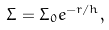Convert formula to latex. <formula><loc_0><loc_0><loc_500><loc_500>\Sigma = \Sigma _ { 0 } e ^ { - r / h } ,</formula> 